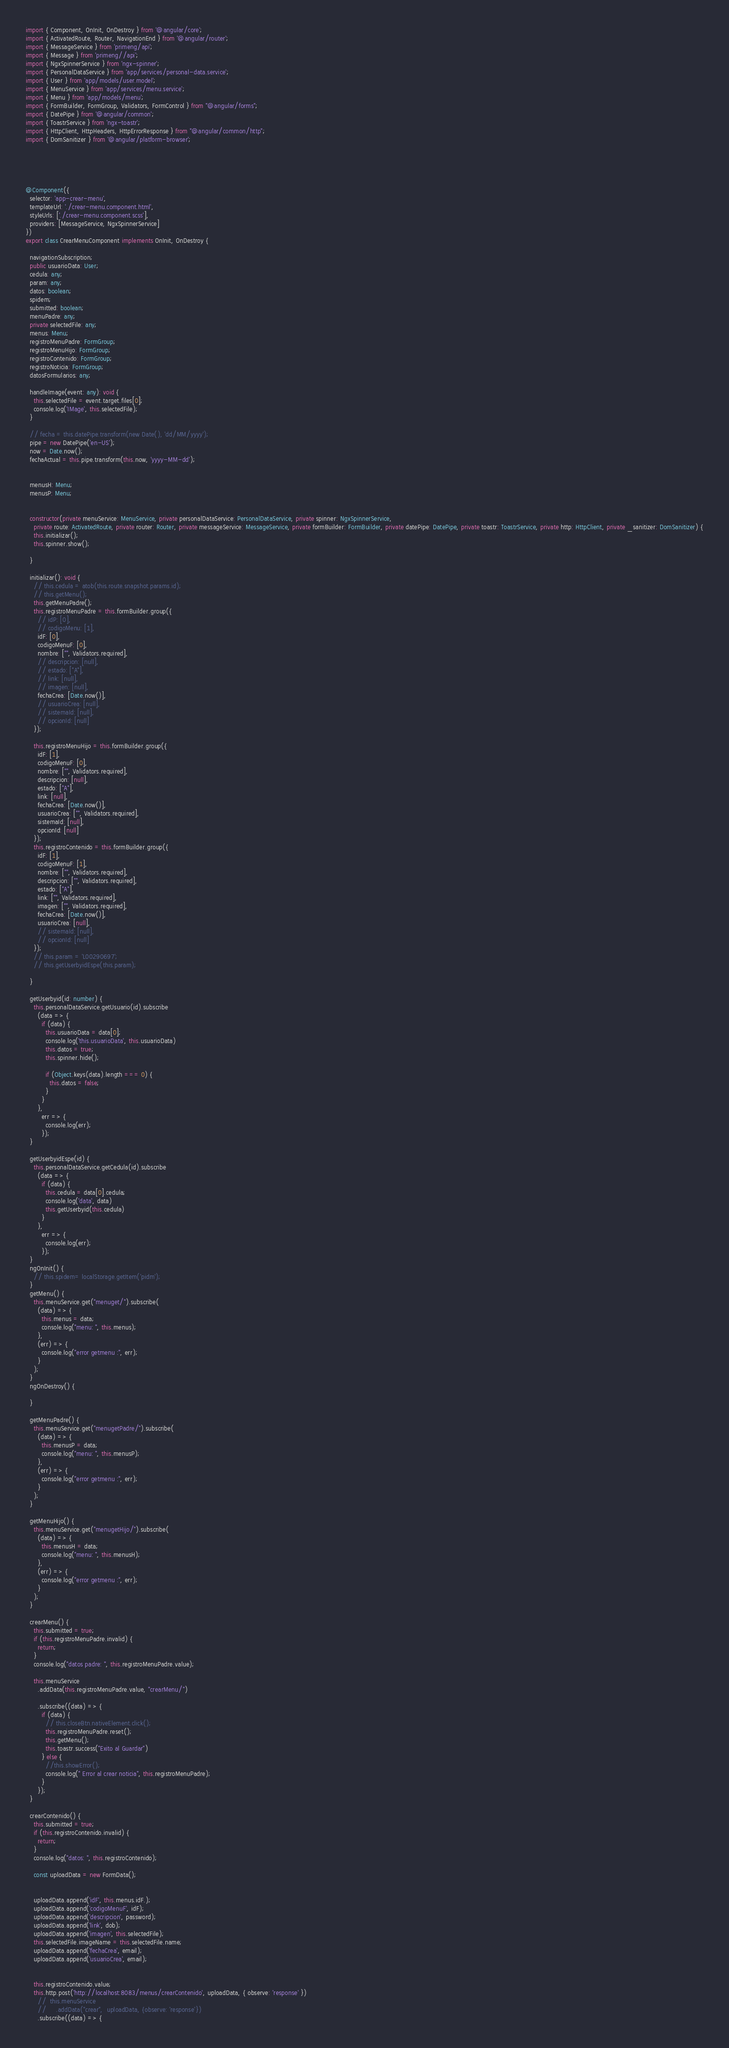Convert code to text. <code><loc_0><loc_0><loc_500><loc_500><_TypeScript_>import { Component, OnInit, OnDestroy } from '@angular/core';
import { ActivatedRoute, Router, NavigationEnd } from '@angular/router';
import { MessageService } from 'primeng/api';
import { Message } from 'primeng//api';
import { NgxSpinnerService } from 'ngx-spinner';
import { PersonalDataService } from 'app/services/personal-data.service';
import { User } from 'app/models/user.model';
import { MenuService } from 'app/services/menu.service';
import { Menu } from 'app/models/menu';
import { FormBuilder, FormGroup, Validators, FormControl } from "@angular/forms";
import { DatePipe } from '@angular/common';
import { ToastrService } from 'ngx-toastr';
import { HttpClient, HttpHeaders, HttpErrorResponse } from "@angular/common/http";
import { DomSanitizer } from '@angular/platform-browser';





@Component({
  selector: 'app-crear-menu',
  templateUrl: './crear-menu.component.html',
  styleUrls: ['./crear-menu.component.scss'],
  providers: [MessageService, NgxSpinnerService]
})
export class CrearMenuComponent implements OnInit, OnDestroy {

  navigationSubscription;
  public usuarioData: User;
  cedula: any;
  param: any;
  datos: boolean;
  spidem;
  submitted: boolean;
  menuPadre: any;
  private selectedFile: any;
  menus: Menu;
  registroMenuPadre: FormGroup;
  registroMenuHijo: FormGroup;
  registroContenido: FormGroup;
  registroNoticia: FormGroup;
  datosFormularios: any;

  handleImage(event: any): void {
    this.selectedFile = event.target.files[0];
    console.log('IMage', this.selectedFile);
  }

  // fecha = this.datePipe.transform(new Date(), 'dd/MM/yyyy');
  pipe = new DatePipe('en-US');
  now = Date.now();
  fechaActual = this.pipe.transform(this.now, 'yyyy-MM-dd');


  menusH: Menu;
  menusP: Menu;


  constructor(private menuService: MenuService, private personalDataService: PersonalDataService, private spinner: NgxSpinnerService,
    private route: ActivatedRoute, private router: Router, private messageService: MessageService, private formBuilder: FormBuilder, private datePipe: DatePipe, private toastr: ToastrService, private http: HttpClient, private _sanitizer: DomSanitizer) {
    this.initializar();
    this.spinner.show();

  }

  initializar(): void {
    // this.cedula = atob(this.route.snapshot.params.id);
    // this.getMenu();
    this.getMenuPadre();
    this.registroMenuPadre = this.formBuilder.group({
      // idP: [0],
      // codigoMenu: [1],
      idF: [0],
      codigoMenuF: [0],
      nombre: ["", Validators.required],
      // descripcion: [null],
      // estado: ["A"],
      // link: [null],
      // imagen: [null],
      fechaCrea: [Date.now()],
      // usuarioCrea: [null],
      // sistemaId: [null],
      // opcionId: [null]
    });

    this.registroMenuHijo = this.formBuilder.group({
      idF: [1],
      codigoMenuF: [0],
      nombre: ["", Validators.required],
      descripcion: [null],
      estado: ["A"],
      link: [null],
      fechaCrea: [Date.now()],
      usuarioCrea: ["", Validators.required],
      sistemaId: [null],
      opcionId: [null]
    });
    this.registroContenido = this.formBuilder.group({
      idF: [1],
      codigoMenuF: [1],
      nombre: ["", Validators.required],
      descripcion: ["", Validators.required],
      estado: ["A"],
      link: ["", Validators.required],
      imagen: ["", Validators.required],
      fechaCrea: [Date.now()],
      usuarioCrea: [null],
      // sistemaId: [null],
      // opcionId: [null]
    });
    // this.param = 'L00290697';
    // this.getUserbyidEspe(this.param);

  }

  getUserbyid(id: number) {
    this.personalDataService.getUsuario(id).subscribe
      (data => {
        if (data) {
          this.usuarioData = data[0];
          console.log('this.usuarioData', this.usuarioData)
          this.datos = true;
          this.spinner.hide();

          if (Object.keys(data).length === 0) {
            this.datos = false;
          }
        }
      },
        err => {
          console.log(err);
        });
  }

  getUserbyidEspe(id) {
    this.personalDataService.getCedula(id).subscribe
      (data => {
        if (data) {
          this.cedula = data[0].cedula;
          console.log('data', data)
          this.getUserbyid(this.cedula)
        }
      },
        err => {
          console.log(err);
        });
  }
  ngOnInit() {
    // this.spidem= localStorage.getItem('pidm');
  }
  getMenu() {
    this.menuService.get("menuget/").subscribe(
      (data) => {
        this.menus = data;
        console.log("menu: ", this.menus);
      },
      (err) => {
        console.log("error getmenu :", err);
      }
    );
  }
  ngOnDestroy() {

  }

  getMenuPadre() {
    this.menuService.get("menugetPadre/").subscribe(
      (data) => {
        this.menusP = data;
        console.log("menu: ", this.menusP);
      },
      (err) => {
        console.log("error getmenu :", err);
      }
    );
  }

  getMenuHijo() {
    this.menuService.get("menugetHijo/").subscribe(
      (data) => {
        this.menusH = data;
        console.log("menu: ", this.menusH);
      },
      (err) => {
        console.log("error getmenu :", err);
      }
    );
  }

  crearMenu() {
    this.submitted = true;
    if (this.registroMenuPadre.invalid) {
      return;
    }
    console.log("datos padre: ", this.registroMenuPadre.value);

    this.menuService
      .addData(this.registroMenuPadre.value, "crearMenu/")

      .subscribe((data) => {
        if (data) {
          // this.closeBtn.nativeElement.click();
          this.registroMenuPadre.reset();
          this.getMenu();
          this.toastr.success("Exito al Guardar")
        } else {
          //this.showError();
          console.log(" Error al crear noticia", this.registroMenuPadre);
        }
      });
  }

  crearContenido() {
    this.submitted = true;
    if (this.registroContenido.invalid) {
      return;
    }
    console.log("datos: ", this.registroContenido);

    const uploadData = new FormData();


    uploadData.append('idF', this.menus.idF.);
    uploadData.append('codigoMenuF', idF);
    uploadData.append('descripcion', password);
    uploadData.append('link', dob);
    uploadData.append('imagen', this.selectedFile);
    this.selectedFile.imageName = this.selectedFile.name;
    uploadData.append('fechaCrea', email);
    uploadData.append('usuarioCrea', email);


    this.registroContenido.value;
    this.http.post('http://localhost:8083/menus/crearContenido', uploadData, { observe: 'response' })
      //  this.menuService
      //     .addData("crear",  uploadData, {observe: 'response'})
      .subscribe((data) => {</code> 